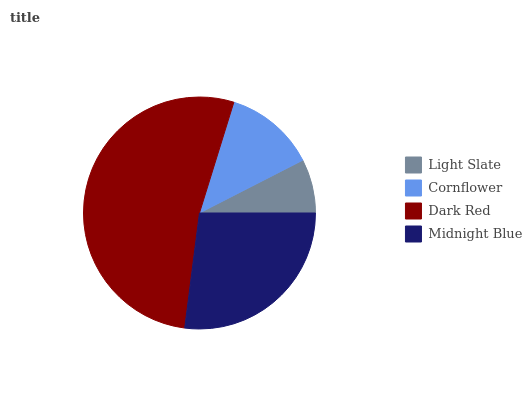Is Light Slate the minimum?
Answer yes or no. Yes. Is Dark Red the maximum?
Answer yes or no. Yes. Is Cornflower the minimum?
Answer yes or no. No. Is Cornflower the maximum?
Answer yes or no. No. Is Cornflower greater than Light Slate?
Answer yes or no. Yes. Is Light Slate less than Cornflower?
Answer yes or no. Yes. Is Light Slate greater than Cornflower?
Answer yes or no. No. Is Cornflower less than Light Slate?
Answer yes or no. No. Is Midnight Blue the high median?
Answer yes or no. Yes. Is Cornflower the low median?
Answer yes or no. Yes. Is Light Slate the high median?
Answer yes or no. No. Is Midnight Blue the low median?
Answer yes or no. No. 